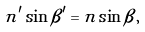<formula> <loc_0><loc_0><loc_500><loc_500>n ^ { \prime } \sin \beta ^ { \prime } = n \sin \beta ,</formula> 